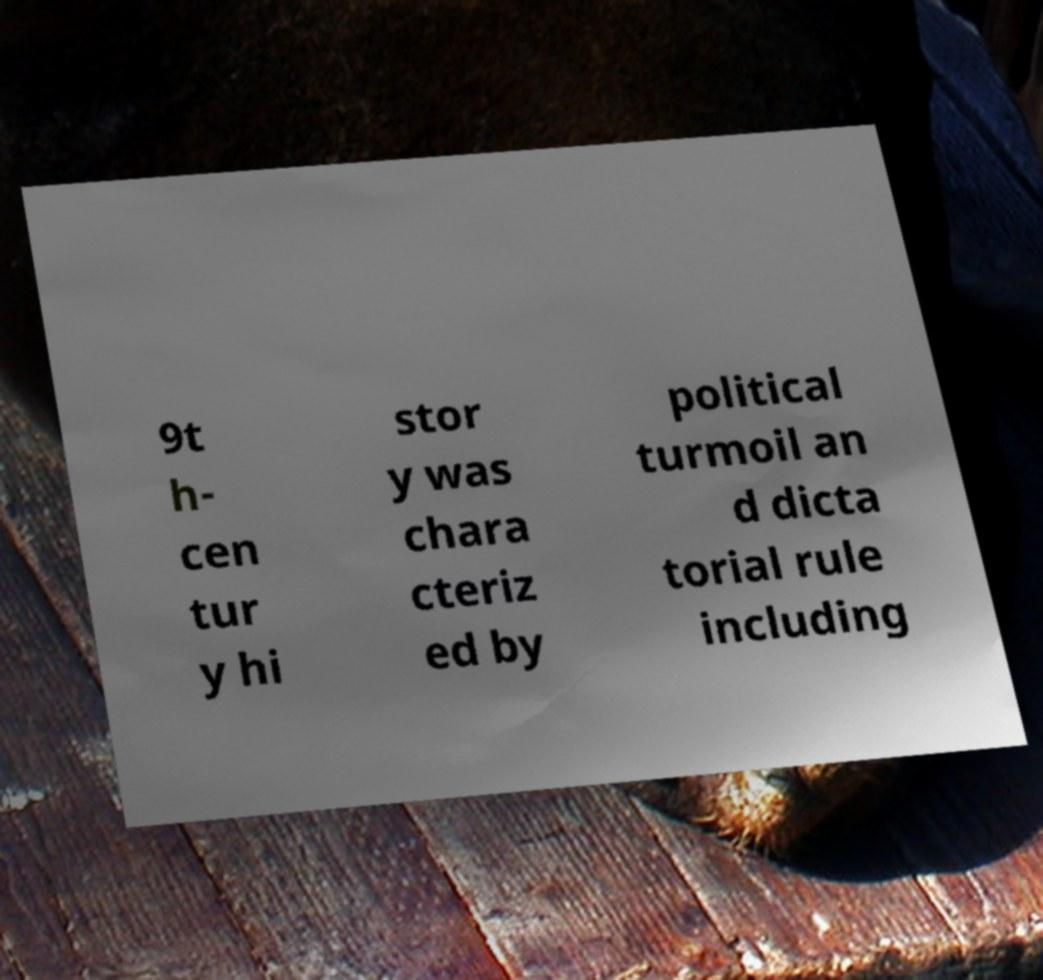Can you read and provide the text displayed in the image?This photo seems to have some interesting text. Can you extract and type it out for me? 9t h- cen tur y hi stor y was chara cteriz ed by political turmoil an d dicta torial rule including 